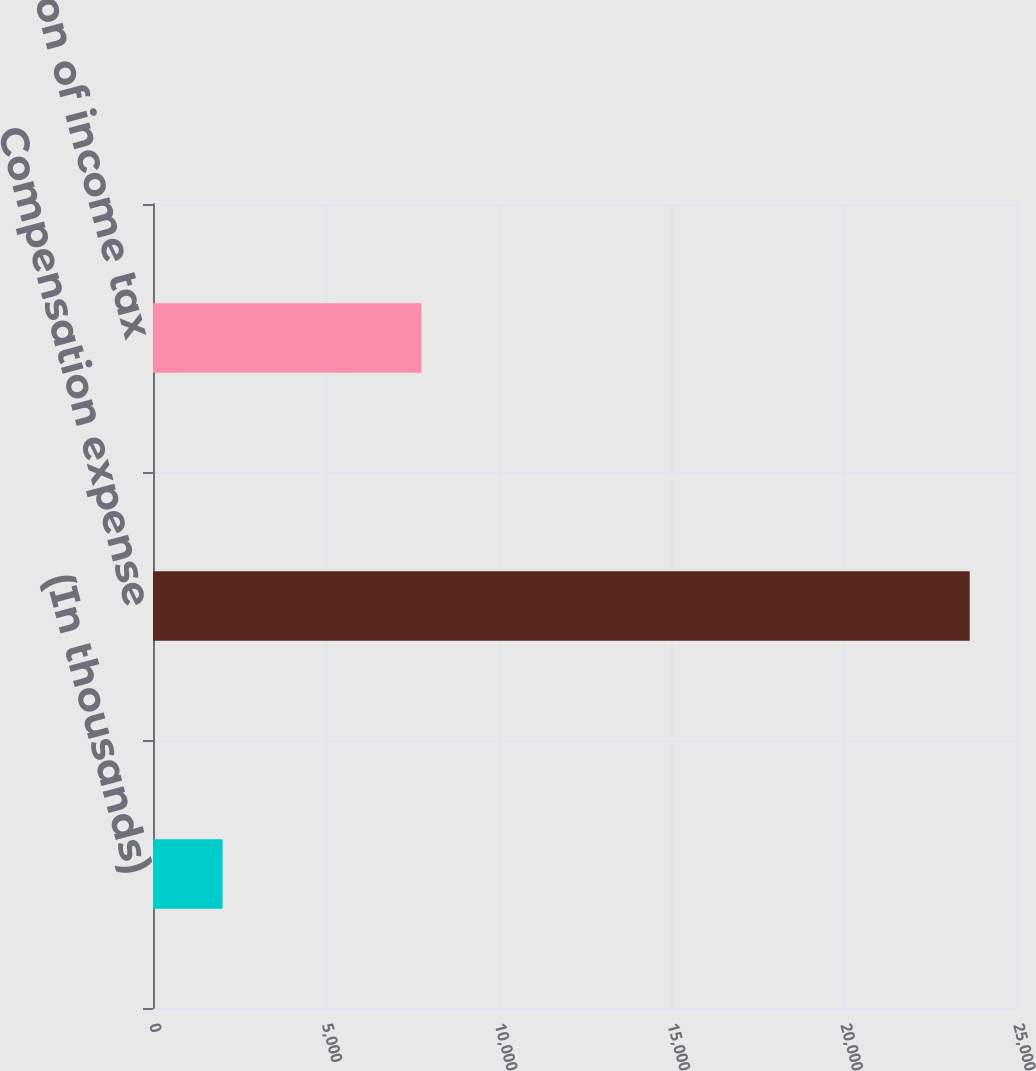<chart> <loc_0><loc_0><loc_500><loc_500><bar_chart><fcel>(In thousands)<fcel>Compensation expense<fcel>Reduction of income tax<nl><fcel>2014<fcel>23632<fcel>7767<nl></chart> 